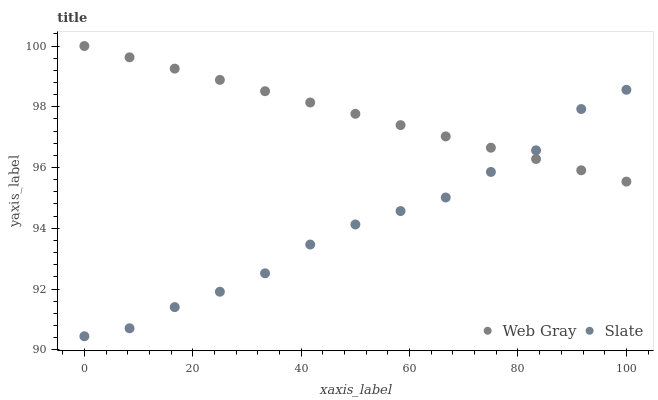Does Slate have the minimum area under the curve?
Answer yes or no. Yes. Does Web Gray have the maximum area under the curve?
Answer yes or no. Yes. Does Web Gray have the minimum area under the curve?
Answer yes or no. No. Is Web Gray the smoothest?
Answer yes or no. Yes. Is Slate the roughest?
Answer yes or no. Yes. Is Web Gray the roughest?
Answer yes or no. No. Does Slate have the lowest value?
Answer yes or no. Yes. Does Web Gray have the lowest value?
Answer yes or no. No. Does Web Gray have the highest value?
Answer yes or no. Yes. Does Web Gray intersect Slate?
Answer yes or no. Yes. Is Web Gray less than Slate?
Answer yes or no. No. Is Web Gray greater than Slate?
Answer yes or no. No. 